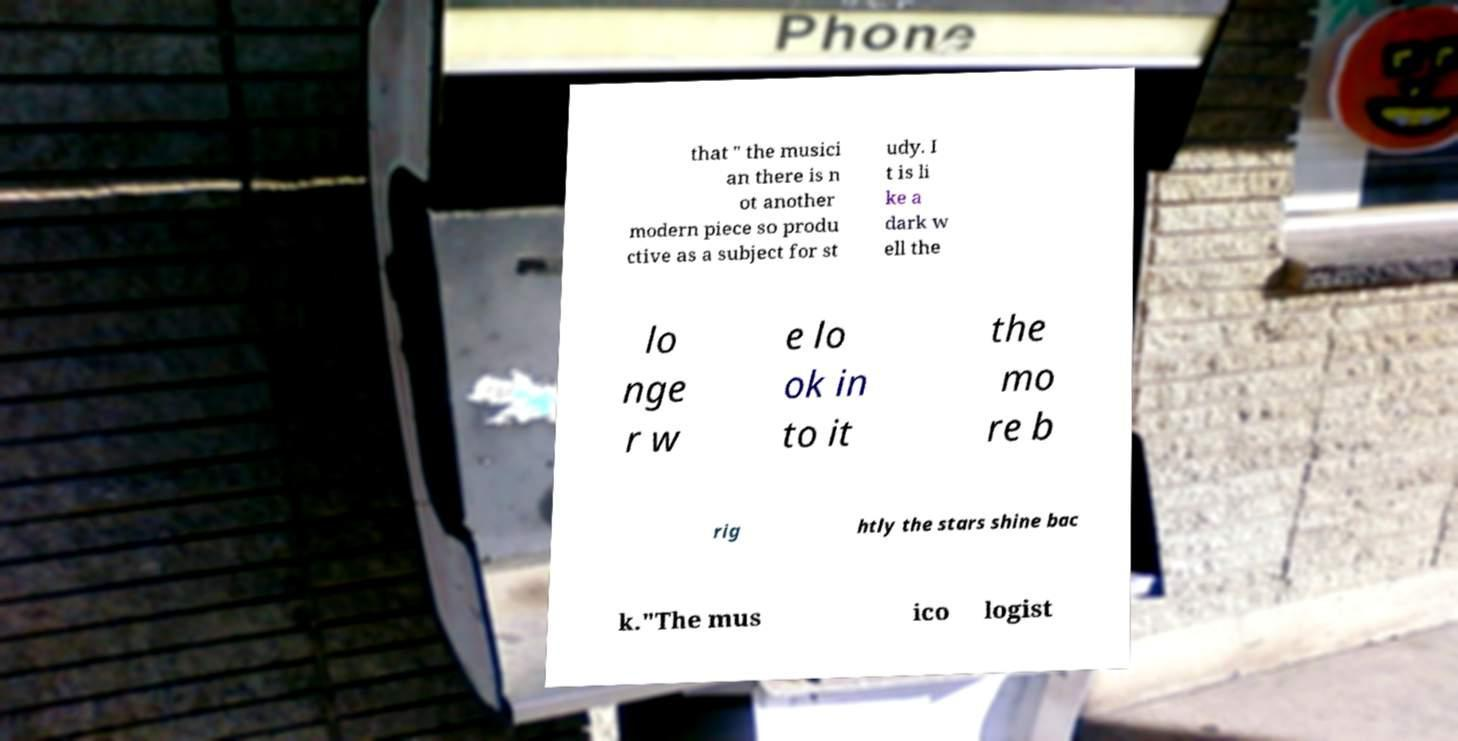Can you read and provide the text displayed in the image?This photo seems to have some interesting text. Can you extract and type it out for me? that " the musici an there is n ot another modern piece so produ ctive as a subject for st udy. I t is li ke a dark w ell the lo nge r w e lo ok in to it the mo re b rig htly the stars shine bac k."The mus ico logist 